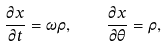<formula> <loc_0><loc_0><loc_500><loc_500>\frac { \partial x } { \partial t } = \omega \rho , \quad \frac { \partial x } { \partial \theta } = \rho ,</formula> 